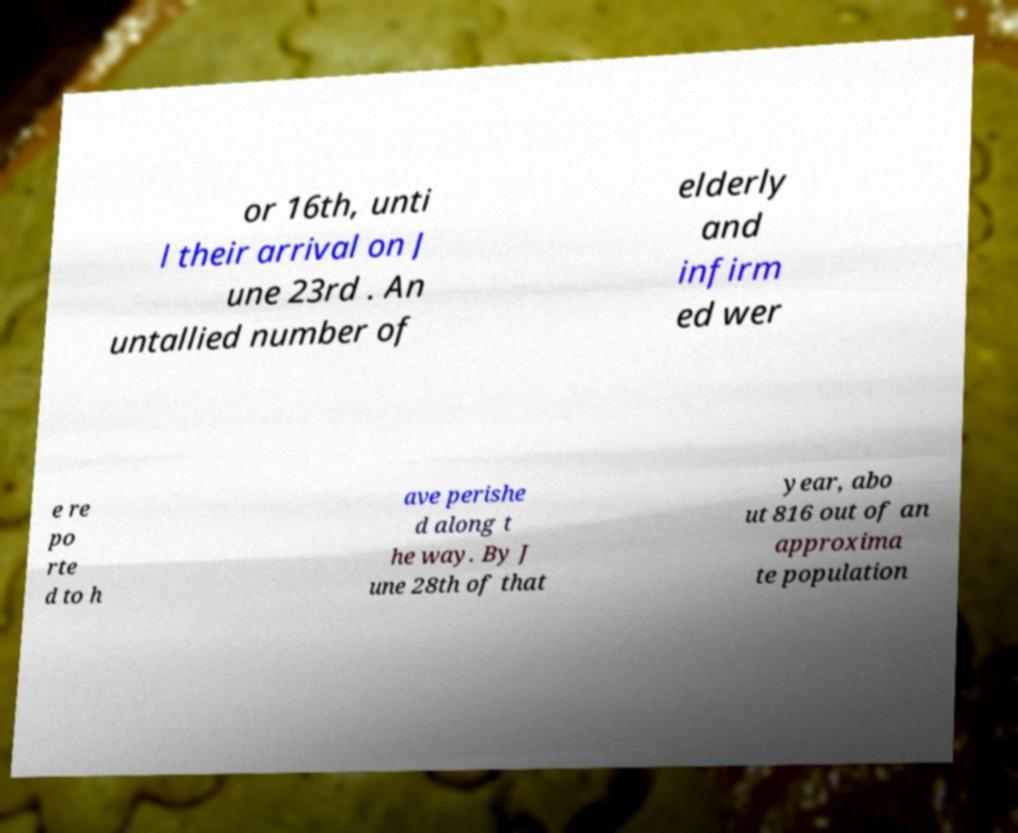Could you extract and type out the text from this image? or 16th, unti l their arrival on J une 23rd . An untallied number of elderly and infirm ed wer e re po rte d to h ave perishe d along t he way. By J une 28th of that year, abo ut 816 out of an approxima te population 